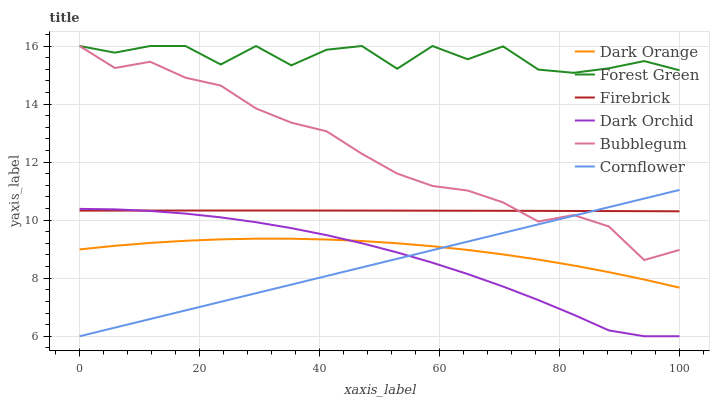Does Cornflower have the minimum area under the curve?
Answer yes or no. Yes. Does Forest Green have the maximum area under the curve?
Answer yes or no. Yes. Does Firebrick have the minimum area under the curve?
Answer yes or no. No. Does Firebrick have the maximum area under the curve?
Answer yes or no. No. Is Cornflower the smoothest?
Answer yes or no. Yes. Is Forest Green the roughest?
Answer yes or no. Yes. Is Firebrick the smoothest?
Answer yes or no. No. Is Firebrick the roughest?
Answer yes or no. No. Does Firebrick have the lowest value?
Answer yes or no. No. Does Forest Green have the highest value?
Answer yes or no. Yes. Does Cornflower have the highest value?
Answer yes or no. No. Is Firebrick less than Forest Green?
Answer yes or no. Yes. Is Forest Green greater than Firebrick?
Answer yes or no. Yes. Does Firebrick intersect Dark Orchid?
Answer yes or no. Yes. Is Firebrick less than Dark Orchid?
Answer yes or no. No. Is Firebrick greater than Dark Orchid?
Answer yes or no. No. Does Firebrick intersect Forest Green?
Answer yes or no. No. 